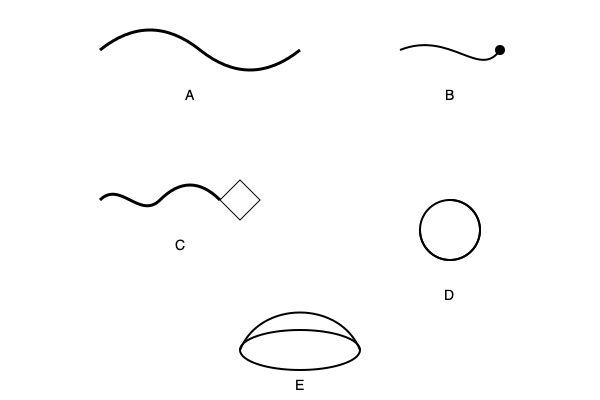Identify the Celtic artifacts depicted in the sketches above by matching the correct labels (A-E) to their corresponding names: Torc, Fibula, Carnyx, Triskelion, and Cauldron. To correctly identify and label the Celtic artifacts, let's analyze each sketch:

1. Sketch A: This curved, open-ended neckpiece is a Torc. Torcs were important symbols of status and power in Celtic society, often made of precious metals.

2. Sketch B: This pin-like object with a curved body and a small circular end is a Fibula. Fibulae were used as clothing fasteners, similar to modern brooches.

3. Sketch C: This long, curved object with a stylized animal head at the end represents a Carnyx. The Carnyx was a type of war trumpet used by Celtic warriors to intimidate enemies in battle.

4. Sketch D: This symmetrical, three-armed spiral design is a Triskelion. It was a common Celtic symbol representing various concepts such as the triple goddess, the three realms (earth, sea, and sky), or the cycles of life.

5. Sketch E: This large, rounded vessel with a wide opening is a Cauldron. Cauldrons held great importance in Celtic culture, often associated with abundance, rebirth, and ritual feasting.

Therefore, the correct matching is:
A - Torc
B - Fibula
C - Carnyx
D - Triskelion
E - Cauldron
Answer: A-Torc, B-Fibula, C-Carnyx, D-Triskelion, E-Cauldron 